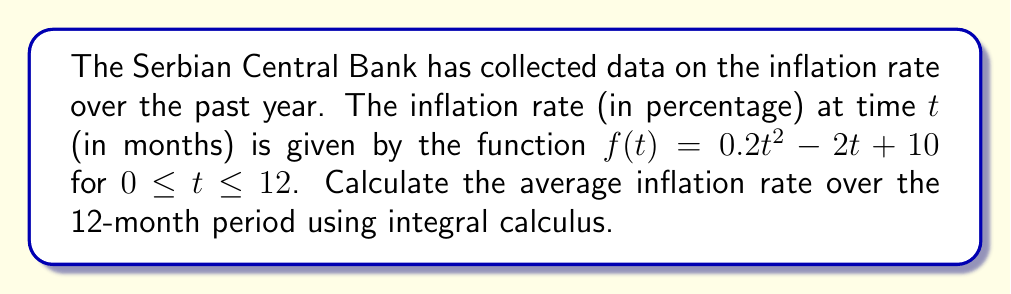Show me your answer to this math problem. To find the average inflation rate over the 12-month period, we need to:

1. Calculate the integral of the inflation rate function over the given time period.
2. Divide the result by the length of the time period.

Step 1: Set up the integral
The average value of a function $f(t)$ over an interval $[a,b]$ is given by:

$$\text{Average} = \frac{1}{b-a} \int_a^b f(t) dt$$

In our case, $a=0$, $b=12$, and $f(t) = 0.2t^2 - 2t + 10$. So we have:

$$\text{Average} = \frac{1}{12} \int_0^{12} (0.2t^2 - 2t + 10) dt$$

Step 2: Solve the integral
$$\begin{align}
\int_0^{12} (0.2t^2 - 2t + 10) dt &= \left[\frac{0.2t^3}{3} - t^2 + 10t\right]_0^{12} \\
&= \left(\frac{0.2(12^3)}{3} - 12^2 + 10(12)\right) - \left(\frac{0.2(0^3)}{3} - 0^2 + 10(0)\right) \\
&= (115.2 - 144 + 120) - 0 \\
&= 91.2
\end{align}$$

Step 3: Calculate the average
$$\text{Average} = \frac{1}{12} \cdot 91.2 = 7.6$$

Therefore, the average inflation rate over the 12-month period is 7.6%.
Answer: 7.6% 